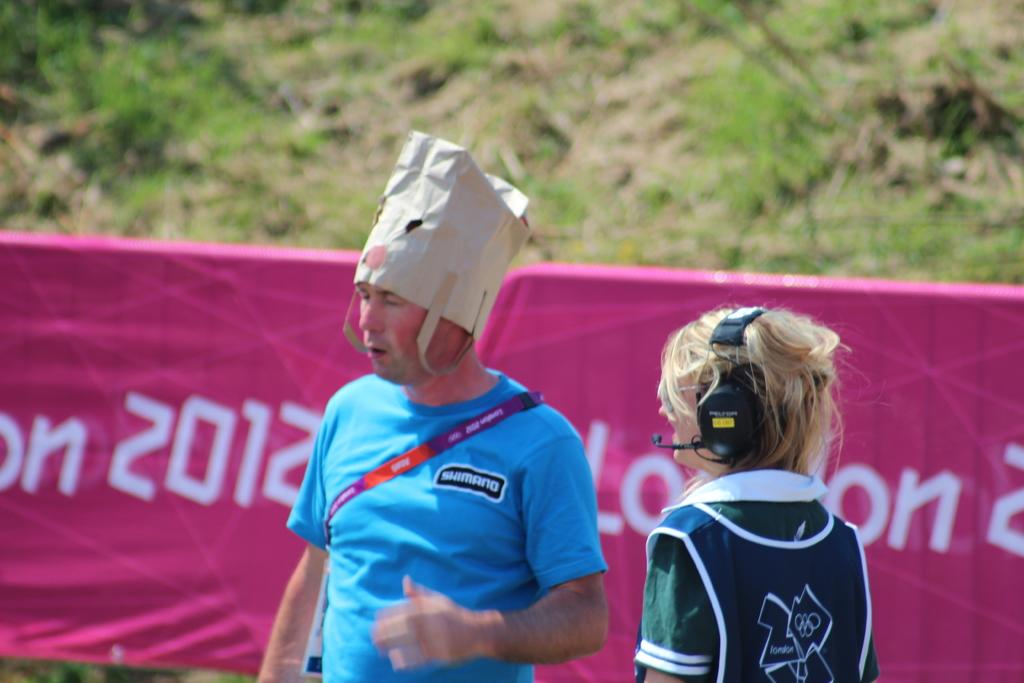<image>
Offer a succinct explanation of the picture presented. The year 2012 is on a pink banner behind people. 